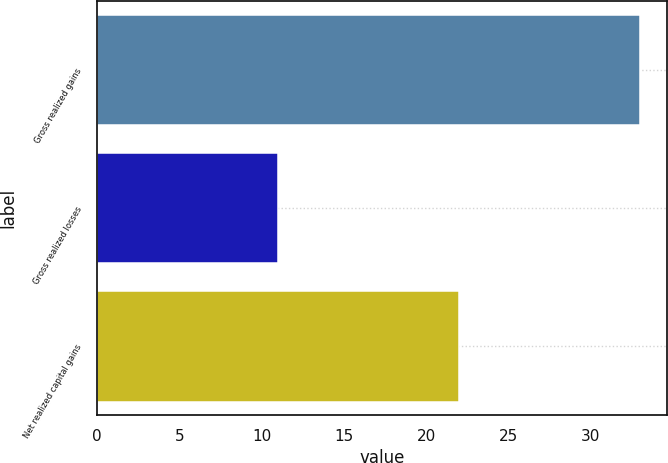Convert chart. <chart><loc_0><loc_0><loc_500><loc_500><bar_chart><fcel>Gross realized gains<fcel>Gross realized losses<fcel>Net realized capital gains<nl><fcel>33<fcel>11<fcel>22<nl></chart> 